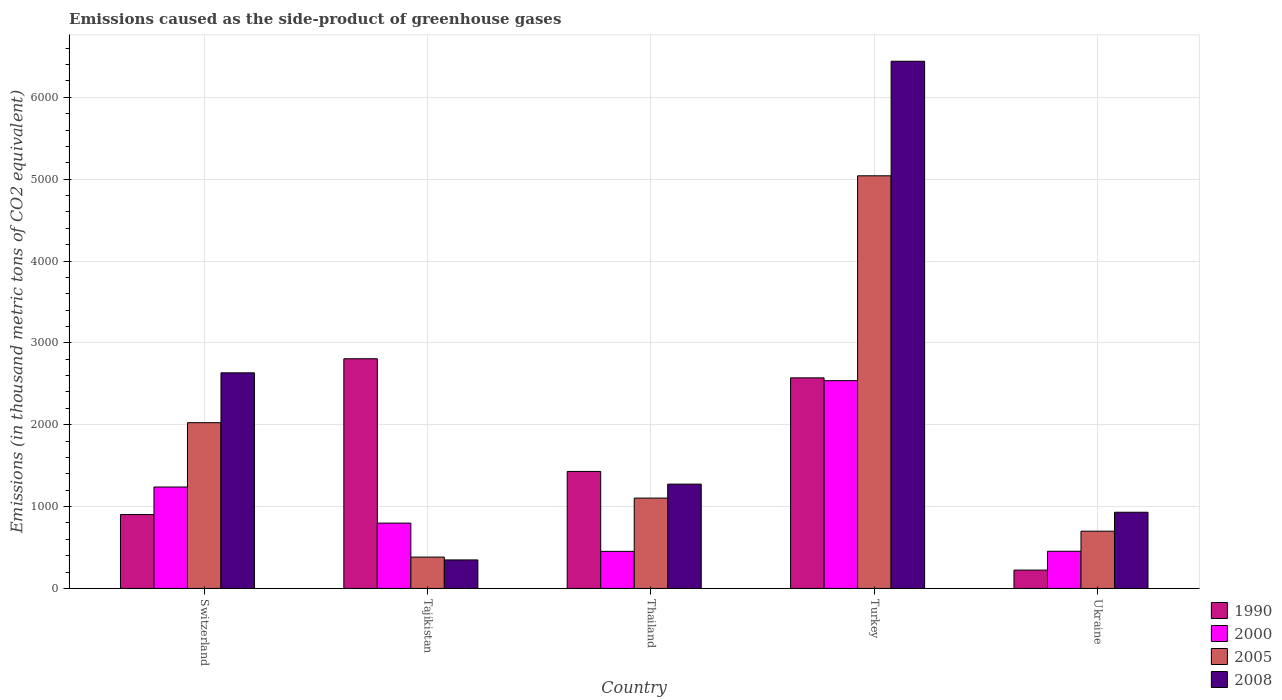How many groups of bars are there?
Your response must be concise. 5. Are the number of bars per tick equal to the number of legend labels?
Keep it short and to the point. Yes. How many bars are there on the 4th tick from the right?
Keep it short and to the point. 4. What is the label of the 3rd group of bars from the left?
Your answer should be very brief. Thailand. In how many cases, is the number of bars for a given country not equal to the number of legend labels?
Your answer should be compact. 0. What is the emissions caused as the side-product of greenhouse gases in 2000 in Ukraine?
Your response must be concise. 454.2. Across all countries, what is the maximum emissions caused as the side-product of greenhouse gases in 2000?
Your answer should be compact. 2538.5. Across all countries, what is the minimum emissions caused as the side-product of greenhouse gases in 2008?
Offer a terse response. 348.3. In which country was the emissions caused as the side-product of greenhouse gases in 2008 minimum?
Your answer should be compact. Tajikistan. What is the total emissions caused as the side-product of greenhouse gases in 1990 in the graph?
Your response must be concise. 7935. What is the difference between the emissions caused as the side-product of greenhouse gases in 1990 in Tajikistan and that in Turkey?
Your response must be concise. 233.4. What is the difference between the emissions caused as the side-product of greenhouse gases in 2008 in Tajikistan and the emissions caused as the side-product of greenhouse gases in 1990 in Switzerland?
Ensure brevity in your answer.  -554.3. What is the average emissions caused as the side-product of greenhouse gases in 2000 per country?
Ensure brevity in your answer.  1096.6. What is the difference between the emissions caused as the side-product of greenhouse gases of/in 2008 and emissions caused as the side-product of greenhouse gases of/in 2005 in Switzerland?
Make the answer very short. 609.1. What is the ratio of the emissions caused as the side-product of greenhouse gases in 2000 in Tajikistan to that in Turkey?
Your answer should be compact. 0.31. Is the emissions caused as the side-product of greenhouse gases in 2008 in Tajikistan less than that in Ukraine?
Give a very brief answer. Yes. Is the difference between the emissions caused as the side-product of greenhouse gases in 2008 in Switzerland and Tajikistan greater than the difference between the emissions caused as the side-product of greenhouse gases in 2005 in Switzerland and Tajikistan?
Offer a very short reply. Yes. What is the difference between the highest and the second highest emissions caused as the side-product of greenhouse gases in 2005?
Give a very brief answer. 3016.3. What is the difference between the highest and the lowest emissions caused as the side-product of greenhouse gases in 2000?
Provide a short and direct response. 2085.4. In how many countries, is the emissions caused as the side-product of greenhouse gases in 2005 greater than the average emissions caused as the side-product of greenhouse gases in 2005 taken over all countries?
Keep it short and to the point. 2. Is the sum of the emissions caused as the side-product of greenhouse gases in 2005 in Switzerland and Tajikistan greater than the maximum emissions caused as the side-product of greenhouse gases in 1990 across all countries?
Ensure brevity in your answer.  No. Is it the case that in every country, the sum of the emissions caused as the side-product of greenhouse gases in 2000 and emissions caused as the side-product of greenhouse gases in 1990 is greater than the sum of emissions caused as the side-product of greenhouse gases in 2008 and emissions caused as the side-product of greenhouse gases in 2005?
Offer a terse response. No. What does the 4th bar from the right in Thailand represents?
Ensure brevity in your answer.  1990. Is it the case that in every country, the sum of the emissions caused as the side-product of greenhouse gases in 2005 and emissions caused as the side-product of greenhouse gases in 2008 is greater than the emissions caused as the side-product of greenhouse gases in 1990?
Provide a succinct answer. No. How many bars are there?
Your answer should be very brief. 20. Are all the bars in the graph horizontal?
Make the answer very short. No. What is the difference between two consecutive major ticks on the Y-axis?
Give a very brief answer. 1000. Are the values on the major ticks of Y-axis written in scientific E-notation?
Your response must be concise. No. Does the graph contain any zero values?
Keep it short and to the point. No. Does the graph contain grids?
Give a very brief answer. Yes. What is the title of the graph?
Make the answer very short. Emissions caused as the side-product of greenhouse gases. What is the label or title of the X-axis?
Offer a very short reply. Country. What is the label or title of the Y-axis?
Give a very brief answer. Emissions (in thousand metric tons of CO2 equivalent). What is the Emissions (in thousand metric tons of CO2 equivalent) in 1990 in Switzerland?
Keep it short and to the point. 902.6. What is the Emissions (in thousand metric tons of CO2 equivalent) in 2000 in Switzerland?
Your response must be concise. 1239.2. What is the Emissions (in thousand metric tons of CO2 equivalent) of 2005 in Switzerland?
Offer a very short reply. 2025. What is the Emissions (in thousand metric tons of CO2 equivalent) in 2008 in Switzerland?
Provide a short and direct response. 2634.1. What is the Emissions (in thousand metric tons of CO2 equivalent) in 1990 in Tajikistan?
Offer a terse response. 2806.1. What is the Emissions (in thousand metric tons of CO2 equivalent) of 2000 in Tajikistan?
Offer a terse response. 798. What is the Emissions (in thousand metric tons of CO2 equivalent) of 2005 in Tajikistan?
Give a very brief answer. 383. What is the Emissions (in thousand metric tons of CO2 equivalent) of 2008 in Tajikistan?
Offer a very short reply. 348.3. What is the Emissions (in thousand metric tons of CO2 equivalent) in 1990 in Thailand?
Provide a succinct answer. 1429.5. What is the Emissions (in thousand metric tons of CO2 equivalent) in 2000 in Thailand?
Your answer should be very brief. 453.1. What is the Emissions (in thousand metric tons of CO2 equivalent) in 2005 in Thailand?
Make the answer very short. 1103.9. What is the Emissions (in thousand metric tons of CO2 equivalent) of 2008 in Thailand?
Keep it short and to the point. 1274.5. What is the Emissions (in thousand metric tons of CO2 equivalent) in 1990 in Turkey?
Your answer should be compact. 2572.7. What is the Emissions (in thousand metric tons of CO2 equivalent) in 2000 in Turkey?
Provide a short and direct response. 2538.5. What is the Emissions (in thousand metric tons of CO2 equivalent) of 2005 in Turkey?
Provide a short and direct response. 5041.3. What is the Emissions (in thousand metric tons of CO2 equivalent) of 2008 in Turkey?
Your answer should be compact. 6441. What is the Emissions (in thousand metric tons of CO2 equivalent) of 1990 in Ukraine?
Your answer should be compact. 224.1. What is the Emissions (in thousand metric tons of CO2 equivalent) of 2000 in Ukraine?
Make the answer very short. 454.2. What is the Emissions (in thousand metric tons of CO2 equivalent) of 2005 in Ukraine?
Your response must be concise. 699.3. What is the Emissions (in thousand metric tons of CO2 equivalent) in 2008 in Ukraine?
Your response must be concise. 930.6. Across all countries, what is the maximum Emissions (in thousand metric tons of CO2 equivalent) in 1990?
Provide a succinct answer. 2806.1. Across all countries, what is the maximum Emissions (in thousand metric tons of CO2 equivalent) of 2000?
Ensure brevity in your answer.  2538.5. Across all countries, what is the maximum Emissions (in thousand metric tons of CO2 equivalent) in 2005?
Your response must be concise. 5041.3. Across all countries, what is the maximum Emissions (in thousand metric tons of CO2 equivalent) of 2008?
Offer a terse response. 6441. Across all countries, what is the minimum Emissions (in thousand metric tons of CO2 equivalent) of 1990?
Offer a terse response. 224.1. Across all countries, what is the minimum Emissions (in thousand metric tons of CO2 equivalent) of 2000?
Your response must be concise. 453.1. Across all countries, what is the minimum Emissions (in thousand metric tons of CO2 equivalent) of 2005?
Provide a succinct answer. 383. Across all countries, what is the minimum Emissions (in thousand metric tons of CO2 equivalent) of 2008?
Provide a short and direct response. 348.3. What is the total Emissions (in thousand metric tons of CO2 equivalent) in 1990 in the graph?
Your answer should be very brief. 7935. What is the total Emissions (in thousand metric tons of CO2 equivalent) of 2000 in the graph?
Give a very brief answer. 5483. What is the total Emissions (in thousand metric tons of CO2 equivalent) of 2005 in the graph?
Make the answer very short. 9252.5. What is the total Emissions (in thousand metric tons of CO2 equivalent) in 2008 in the graph?
Provide a succinct answer. 1.16e+04. What is the difference between the Emissions (in thousand metric tons of CO2 equivalent) in 1990 in Switzerland and that in Tajikistan?
Offer a very short reply. -1903.5. What is the difference between the Emissions (in thousand metric tons of CO2 equivalent) of 2000 in Switzerland and that in Tajikistan?
Offer a very short reply. 441.2. What is the difference between the Emissions (in thousand metric tons of CO2 equivalent) of 2005 in Switzerland and that in Tajikistan?
Provide a short and direct response. 1642. What is the difference between the Emissions (in thousand metric tons of CO2 equivalent) in 2008 in Switzerland and that in Tajikistan?
Your answer should be compact. 2285.8. What is the difference between the Emissions (in thousand metric tons of CO2 equivalent) in 1990 in Switzerland and that in Thailand?
Your answer should be very brief. -526.9. What is the difference between the Emissions (in thousand metric tons of CO2 equivalent) in 2000 in Switzerland and that in Thailand?
Your answer should be compact. 786.1. What is the difference between the Emissions (in thousand metric tons of CO2 equivalent) of 2005 in Switzerland and that in Thailand?
Your answer should be very brief. 921.1. What is the difference between the Emissions (in thousand metric tons of CO2 equivalent) of 2008 in Switzerland and that in Thailand?
Make the answer very short. 1359.6. What is the difference between the Emissions (in thousand metric tons of CO2 equivalent) in 1990 in Switzerland and that in Turkey?
Your response must be concise. -1670.1. What is the difference between the Emissions (in thousand metric tons of CO2 equivalent) of 2000 in Switzerland and that in Turkey?
Make the answer very short. -1299.3. What is the difference between the Emissions (in thousand metric tons of CO2 equivalent) in 2005 in Switzerland and that in Turkey?
Ensure brevity in your answer.  -3016.3. What is the difference between the Emissions (in thousand metric tons of CO2 equivalent) in 2008 in Switzerland and that in Turkey?
Provide a short and direct response. -3806.9. What is the difference between the Emissions (in thousand metric tons of CO2 equivalent) of 1990 in Switzerland and that in Ukraine?
Offer a very short reply. 678.5. What is the difference between the Emissions (in thousand metric tons of CO2 equivalent) of 2000 in Switzerland and that in Ukraine?
Offer a very short reply. 785. What is the difference between the Emissions (in thousand metric tons of CO2 equivalent) of 2005 in Switzerland and that in Ukraine?
Provide a short and direct response. 1325.7. What is the difference between the Emissions (in thousand metric tons of CO2 equivalent) of 2008 in Switzerland and that in Ukraine?
Your response must be concise. 1703.5. What is the difference between the Emissions (in thousand metric tons of CO2 equivalent) of 1990 in Tajikistan and that in Thailand?
Offer a terse response. 1376.6. What is the difference between the Emissions (in thousand metric tons of CO2 equivalent) in 2000 in Tajikistan and that in Thailand?
Your answer should be compact. 344.9. What is the difference between the Emissions (in thousand metric tons of CO2 equivalent) of 2005 in Tajikistan and that in Thailand?
Your response must be concise. -720.9. What is the difference between the Emissions (in thousand metric tons of CO2 equivalent) of 2008 in Tajikistan and that in Thailand?
Your response must be concise. -926.2. What is the difference between the Emissions (in thousand metric tons of CO2 equivalent) in 1990 in Tajikistan and that in Turkey?
Your answer should be compact. 233.4. What is the difference between the Emissions (in thousand metric tons of CO2 equivalent) in 2000 in Tajikistan and that in Turkey?
Offer a very short reply. -1740.5. What is the difference between the Emissions (in thousand metric tons of CO2 equivalent) in 2005 in Tajikistan and that in Turkey?
Provide a succinct answer. -4658.3. What is the difference between the Emissions (in thousand metric tons of CO2 equivalent) of 2008 in Tajikistan and that in Turkey?
Offer a very short reply. -6092.7. What is the difference between the Emissions (in thousand metric tons of CO2 equivalent) of 1990 in Tajikistan and that in Ukraine?
Ensure brevity in your answer.  2582. What is the difference between the Emissions (in thousand metric tons of CO2 equivalent) in 2000 in Tajikistan and that in Ukraine?
Your answer should be compact. 343.8. What is the difference between the Emissions (in thousand metric tons of CO2 equivalent) in 2005 in Tajikistan and that in Ukraine?
Your answer should be very brief. -316.3. What is the difference between the Emissions (in thousand metric tons of CO2 equivalent) of 2008 in Tajikistan and that in Ukraine?
Your answer should be compact. -582.3. What is the difference between the Emissions (in thousand metric tons of CO2 equivalent) of 1990 in Thailand and that in Turkey?
Your response must be concise. -1143.2. What is the difference between the Emissions (in thousand metric tons of CO2 equivalent) in 2000 in Thailand and that in Turkey?
Your answer should be compact. -2085.4. What is the difference between the Emissions (in thousand metric tons of CO2 equivalent) in 2005 in Thailand and that in Turkey?
Provide a short and direct response. -3937.4. What is the difference between the Emissions (in thousand metric tons of CO2 equivalent) of 2008 in Thailand and that in Turkey?
Give a very brief answer. -5166.5. What is the difference between the Emissions (in thousand metric tons of CO2 equivalent) in 1990 in Thailand and that in Ukraine?
Ensure brevity in your answer.  1205.4. What is the difference between the Emissions (in thousand metric tons of CO2 equivalent) in 2000 in Thailand and that in Ukraine?
Your answer should be very brief. -1.1. What is the difference between the Emissions (in thousand metric tons of CO2 equivalent) of 2005 in Thailand and that in Ukraine?
Provide a short and direct response. 404.6. What is the difference between the Emissions (in thousand metric tons of CO2 equivalent) in 2008 in Thailand and that in Ukraine?
Keep it short and to the point. 343.9. What is the difference between the Emissions (in thousand metric tons of CO2 equivalent) of 1990 in Turkey and that in Ukraine?
Ensure brevity in your answer.  2348.6. What is the difference between the Emissions (in thousand metric tons of CO2 equivalent) of 2000 in Turkey and that in Ukraine?
Provide a short and direct response. 2084.3. What is the difference between the Emissions (in thousand metric tons of CO2 equivalent) of 2005 in Turkey and that in Ukraine?
Make the answer very short. 4342. What is the difference between the Emissions (in thousand metric tons of CO2 equivalent) in 2008 in Turkey and that in Ukraine?
Ensure brevity in your answer.  5510.4. What is the difference between the Emissions (in thousand metric tons of CO2 equivalent) in 1990 in Switzerland and the Emissions (in thousand metric tons of CO2 equivalent) in 2000 in Tajikistan?
Your answer should be very brief. 104.6. What is the difference between the Emissions (in thousand metric tons of CO2 equivalent) of 1990 in Switzerland and the Emissions (in thousand metric tons of CO2 equivalent) of 2005 in Tajikistan?
Offer a terse response. 519.6. What is the difference between the Emissions (in thousand metric tons of CO2 equivalent) in 1990 in Switzerland and the Emissions (in thousand metric tons of CO2 equivalent) in 2008 in Tajikistan?
Your response must be concise. 554.3. What is the difference between the Emissions (in thousand metric tons of CO2 equivalent) in 2000 in Switzerland and the Emissions (in thousand metric tons of CO2 equivalent) in 2005 in Tajikistan?
Offer a terse response. 856.2. What is the difference between the Emissions (in thousand metric tons of CO2 equivalent) in 2000 in Switzerland and the Emissions (in thousand metric tons of CO2 equivalent) in 2008 in Tajikistan?
Give a very brief answer. 890.9. What is the difference between the Emissions (in thousand metric tons of CO2 equivalent) in 2005 in Switzerland and the Emissions (in thousand metric tons of CO2 equivalent) in 2008 in Tajikistan?
Your response must be concise. 1676.7. What is the difference between the Emissions (in thousand metric tons of CO2 equivalent) of 1990 in Switzerland and the Emissions (in thousand metric tons of CO2 equivalent) of 2000 in Thailand?
Ensure brevity in your answer.  449.5. What is the difference between the Emissions (in thousand metric tons of CO2 equivalent) of 1990 in Switzerland and the Emissions (in thousand metric tons of CO2 equivalent) of 2005 in Thailand?
Your answer should be compact. -201.3. What is the difference between the Emissions (in thousand metric tons of CO2 equivalent) in 1990 in Switzerland and the Emissions (in thousand metric tons of CO2 equivalent) in 2008 in Thailand?
Give a very brief answer. -371.9. What is the difference between the Emissions (in thousand metric tons of CO2 equivalent) in 2000 in Switzerland and the Emissions (in thousand metric tons of CO2 equivalent) in 2005 in Thailand?
Your answer should be compact. 135.3. What is the difference between the Emissions (in thousand metric tons of CO2 equivalent) of 2000 in Switzerland and the Emissions (in thousand metric tons of CO2 equivalent) of 2008 in Thailand?
Offer a terse response. -35.3. What is the difference between the Emissions (in thousand metric tons of CO2 equivalent) in 2005 in Switzerland and the Emissions (in thousand metric tons of CO2 equivalent) in 2008 in Thailand?
Offer a terse response. 750.5. What is the difference between the Emissions (in thousand metric tons of CO2 equivalent) in 1990 in Switzerland and the Emissions (in thousand metric tons of CO2 equivalent) in 2000 in Turkey?
Ensure brevity in your answer.  -1635.9. What is the difference between the Emissions (in thousand metric tons of CO2 equivalent) of 1990 in Switzerland and the Emissions (in thousand metric tons of CO2 equivalent) of 2005 in Turkey?
Offer a very short reply. -4138.7. What is the difference between the Emissions (in thousand metric tons of CO2 equivalent) in 1990 in Switzerland and the Emissions (in thousand metric tons of CO2 equivalent) in 2008 in Turkey?
Your answer should be very brief. -5538.4. What is the difference between the Emissions (in thousand metric tons of CO2 equivalent) of 2000 in Switzerland and the Emissions (in thousand metric tons of CO2 equivalent) of 2005 in Turkey?
Your response must be concise. -3802.1. What is the difference between the Emissions (in thousand metric tons of CO2 equivalent) in 2000 in Switzerland and the Emissions (in thousand metric tons of CO2 equivalent) in 2008 in Turkey?
Your response must be concise. -5201.8. What is the difference between the Emissions (in thousand metric tons of CO2 equivalent) in 2005 in Switzerland and the Emissions (in thousand metric tons of CO2 equivalent) in 2008 in Turkey?
Provide a succinct answer. -4416. What is the difference between the Emissions (in thousand metric tons of CO2 equivalent) in 1990 in Switzerland and the Emissions (in thousand metric tons of CO2 equivalent) in 2000 in Ukraine?
Keep it short and to the point. 448.4. What is the difference between the Emissions (in thousand metric tons of CO2 equivalent) of 1990 in Switzerland and the Emissions (in thousand metric tons of CO2 equivalent) of 2005 in Ukraine?
Provide a short and direct response. 203.3. What is the difference between the Emissions (in thousand metric tons of CO2 equivalent) of 1990 in Switzerland and the Emissions (in thousand metric tons of CO2 equivalent) of 2008 in Ukraine?
Ensure brevity in your answer.  -28. What is the difference between the Emissions (in thousand metric tons of CO2 equivalent) of 2000 in Switzerland and the Emissions (in thousand metric tons of CO2 equivalent) of 2005 in Ukraine?
Offer a terse response. 539.9. What is the difference between the Emissions (in thousand metric tons of CO2 equivalent) in 2000 in Switzerland and the Emissions (in thousand metric tons of CO2 equivalent) in 2008 in Ukraine?
Ensure brevity in your answer.  308.6. What is the difference between the Emissions (in thousand metric tons of CO2 equivalent) of 2005 in Switzerland and the Emissions (in thousand metric tons of CO2 equivalent) of 2008 in Ukraine?
Your answer should be compact. 1094.4. What is the difference between the Emissions (in thousand metric tons of CO2 equivalent) in 1990 in Tajikistan and the Emissions (in thousand metric tons of CO2 equivalent) in 2000 in Thailand?
Make the answer very short. 2353. What is the difference between the Emissions (in thousand metric tons of CO2 equivalent) in 1990 in Tajikistan and the Emissions (in thousand metric tons of CO2 equivalent) in 2005 in Thailand?
Give a very brief answer. 1702.2. What is the difference between the Emissions (in thousand metric tons of CO2 equivalent) of 1990 in Tajikistan and the Emissions (in thousand metric tons of CO2 equivalent) of 2008 in Thailand?
Keep it short and to the point. 1531.6. What is the difference between the Emissions (in thousand metric tons of CO2 equivalent) of 2000 in Tajikistan and the Emissions (in thousand metric tons of CO2 equivalent) of 2005 in Thailand?
Your answer should be very brief. -305.9. What is the difference between the Emissions (in thousand metric tons of CO2 equivalent) in 2000 in Tajikistan and the Emissions (in thousand metric tons of CO2 equivalent) in 2008 in Thailand?
Make the answer very short. -476.5. What is the difference between the Emissions (in thousand metric tons of CO2 equivalent) of 2005 in Tajikistan and the Emissions (in thousand metric tons of CO2 equivalent) of 2008 in Thailand?
Make the answer very short. -891.5. What is the difference between the Emissions (in thousand metric tons of CO2 equivalent) in 1990 in Tajikistan and the Emissions (in thousand metric tons of CO2 equivalent) in 2000 in Turkey?
Keep it short and to the point. 267.6. What is the difference between the Emissions (in thousand metric tons of CO2 equivalent) of 1990 in Tajikistan and the Emissions (in thousand metric tons of CO2 equivalent) of 2005 in Turkey?
Offer a very short reply. -2235.2. What is the difference between the Emissions (in thousand metric tons of CO2 equivalent) of 1990 in Tajikistan and the Emissions (in thousand metric tons of CO2 equivalent) of 2008 in Turkey?
Your answer should be compact. -3634.9. What is the difference between the Emissions (in thousand metric tons of CO2 equivalent) of 2000 in Tajikistan and the Emissions (in thousand metric tons of CO2 equivalent) of 2005 in Turkey?
Make the answer very short. -4243.3. What is the difference between the Emissions (in thousand metric tons of CO2 equivalent) of 2000 in Tajikistan and the Emissions (in thousand metric tons of CO2 equivalent) of 2008 in Turkey?
Provide a short and direct response. -5643. What is the difference between the Emissions (in thousand metric tons of CO2 equivalent) in 2005 in Tajikistan and the Emissions (in thousand metric tons of CO2 equivalent) in 2008 in Turkey?
Your answer should be very brief. -6058. What is the difference between the Emissions (in thousand metric tons of CO2 equivalent) in 1990 in Tajikistan and the Emissions (in thousand metric tons of CO2 equivalent) in 2000 in Ukraine?
Provide a succinct answer. 2351.9. What is the difference between the Emissions (in thousand metric tons of CO2 equivalent) of 1990 in Tajikistan and the Emissions (in thousand metric tons of CO2 equivalent) of 2005 in Ukraine?
Your response must be concise. 2106.8. What is the difference between the Emissions (in thousand metric tons of CO2 equivalent) of 1990 in Tajikistan and the Emissions (in thousand metric tons of CO2 equivalent) of 2008 in Ukraine?
Give a very brief answer. 1875.5. What is the difference between the Emissions (in thousand metric tons of CO2 equivalent) in 2000 in Tajikistan and the Emissions (in thousand metric tons of CO2 equivalent) in 2005 in Ukraine?
Your answer should be compact. 98.7. What is the difference between the Emissions (in thousand metric tons of CO2 equivalent) in 2000 in Tajikistan and the Emissions (in thousand metric tons of CO2 equivalent) in 2008 in Ukraine?
Your response must be concise. -132.6. What is the difference between the Emissions (in thousand metric tons of CO2 equivalent) of 2005 in Tajikistan and the Emissions (in thousand metric tons of CO2 equivalent) of 2008 in Ukraine?
Make the answer very short. -547.6. What is the difference between the Emissions (in thousand metric tons of CO2 equivalent) in 1990 in Thailand and the Emissions (in thousand metric tons of CO2 equivalent) in 2000 in Turkey?
Ensure brevity in your answer.  -1109. What is the difference between the Emissions (in thousand metric tons of CO2 equivalent) of 1990 in Thailand and the Emissions (in thousand metric tons of CO2 equivalent) of 2005 in Turkey?
Provide a succinct answer. -3611.8. What is the difference between the Emissions (in thousand metric tons of CO2 equivalent) of 1990 in Thailand and the Emissions (in thousand metric tons of CO2 equivalent) of 2008 in Turkey?
Your response must be concise. -5011.5. What is the difference between the Emissions (in thousand metric tons of CO2 equivalent) of 2000 in Thailand and the Emissions (in thousand metric tons of CO2 equivalent) of 2005 in Turkey?
Provide a succinct answer. -4588.2. What is the difference between the Emissions (in thousand metric tons of CO2 equivalent) in 2000 in Thailand and the Emissions (in thousand metric tons of CO2 equivalent) in 2008 in Turkey?
Make the answer very short. -5987.9. What is the difference between the Emissions (in thousand metric tons of CO2 equivalent) of 2005 in Thailand and the Emissions (in thousand metric tons of CO2 equivalent) of 2008 in Turkey?
Ensure brevity in your answer.  -5337.1. What is the difference between the Emissions (in thousand metric tons of CO2 equivalent) in 1990 in Thailand and the Emissions (in thousand metric tons of CO2 equivalent) in 2000 in Ukraine?
Keep it short and to the point. 975.3. What is the difference between the Emissions (in thousand metric tons of CO2 equivalent) in 1990 in Thailand and the Emissions (in thousand metric tons of CO2 equivalent) in 2005 in Ukraine?
Your response must be concise. 730.2. What is the difference between the Emissions (in thousand metric tons of CO2 equivalent) of 1990 in Thailand and the Emissions (in thousand metric tons of CO2 equivalent) of 2008 in Ukraine?
Ensure brevity in your answer.  498.9. What is the difference between the Emissions (in thousand metric tons of CO2 equivalent) of 2000 in Thailand and the Emissions (in thousand metric tons of CO2 equivalent) of 2005 in Ukraine?
Your response must be concise. -246.2. What is the difference between the Emissions (in thousand metric tons of CO2 equivalent) of 2000 in Thailand and the Emissions (in thousand metric tons of CO2 equivalent) of 2008 in Ukraine?
Your answer should be very brief. -477.5. What is the difference between the Emissions (in thousand metric tons of CO2 equivalent) of 2005 in Thailand and the Emissions (in thousand metric tons of CO2 equivalent) of 2008 in Ukraine?
Give a very brief answer. 173.3. What is the difference between the Emissions (in thousand metric tons of CO2 equivalent) in 1990 in Turkey and the Emissions (in thousand metric tons of CO2 equivalent) in 2000 in Ukraine?
Offer a very short reply. 2118.5. What is the difference between the Emissions (in thousand metric tons of CO2 equivalent) of 1990 in Turkey and the Emissions (in thousand metric tons of CO2 equivalent) of 2005 in Ukraine?
Keep it short and to the point. 1873.4. What is the difference between the Emissions (in thousand metric tons of CO2 equivalent) in 1990 in Turkey and the Emissions (in thousand metric tons of CO2 equivalent) in 2008 in Ukraine?
Keep it short and to the point. 1642.1. What is the difference between the Emissions (in thousand metric tons of CO2 equivalent) of 2000 in Turkey and the Emissions (in thousand metric tons of CO2 equivalent) of 2005 in Ukraine?
Make the answer very short. 1839.2. What is the difference between the Emissions (in thousand metric tons of CO2 equivalent) in 2000 in Turkey and the Emissions (in thousand metric tons of CO2 equivalent) in 2008 in Ukraine?
Ensure brevity in your answer.  1607.9. What is the difference between the Emissions (in thousand metric tons of CO2 equivalent) in 2005 in Turkey and the Emissions (in thousand metric tons of CO2 equivalent) in 2008 in Ukraine?
Provide a succinct answer. 4110.7. What is the average Emissions (in thousand metric tons of CO2 equivalent) in 1990 per country?
Give a very brief answer. 1587. What is the average Emissions (in thousand metric tons of CO2 equivalent) in 2000 per country?
Ensure brevity in your answer.  1096.6. What is the average Emissions (in thousand metric tons of CO2 equivalent) in 2005 per country?
Provide a short and direct response. 1850.5. What is the average Emissions (in thousand metric tons of CO2 equivalent) in 2008 per country?
Keep it short and to the point. 2325.7. What is the difference between the Emissions (in thousand metric tons of CO2 equivalent) of 1990 and Emissions (in thousand metric tons of CO2 equivalent) of 2000 in Switzerland?
Make the answer very short. -336.6. What is the difference between the Emissions (in thousand metric tons of CO2 equivalent) of 1990 and Emissions (in thousand metric tons of CO2 equivalent) of 2005 in Switzerland?
Offer a very short reply. -1122.4. What is the difference between the Emissions (in thousand metric tons of CO2 equivalent) in 1990 and Emissions (in thousand metric tons of CO2 equivalent) in 2008 in Switzerland?
Your response must be concise. -1731.5. What is the difference between the Emissions (in thousand metric tons of CO2 equivalent) of 2000 and Emissions (in thousand metric tons of CO2 equivalent) of 2005 in Switzerland?
Offer a terse response. -785.8. What is the difference between the Emissions (in thousand metric tons of CO2 equivalent) in 2000 and Emissions (in thousand metric tons of CO2 equivalent) in 2008 in Switzerland?
Make the answer very short. -1394.9. What is the difference between the Emissions (in thousand metric tons of CO2 equivalent) of 2005 and Emissions (in thousand metric tons of CO2 equivalent) of 2008 in Switzerland?
Offer a terse response. -609.1. What is the difference between the Emissions (in thousand metric tons of CO2 equivalent) of 1990 and Emissions (in thousand metric tons of CO2 equivalent) of 2000 in Tajikistan?
Provide a succinct answer. 2008.1. What is the difference between the Emissions (in thousand metric tons of CO2 equivalent) in 1990 and Emissions (in thousand metric tons of CO2 equivalent) in 2005 in Tajikistan?
Your response must be concise. 2423.1. What is the difference between the Emissions (in thousand metric tons of CO2 equivalent) of 1990 and Emissions (in thousand metric tons of CO2 equivalent) of 2008 in Tajikistan?
Provide a succinct answer. 2457.8. What is the difference between the Emissions (in thousand metric tons of CO2 equivalent) of 2000 and Emissions (in thousand metric tons of CO2 equivalent) of 2005 in Tajikistan?
Make the answer very short. 415. What is the difference between the Emissions (in thousand metric tons of CO2 equivalent) in 2000 and Emissions (in thousand metric tons of CO2 equivalent) in 2008 in Tajikistan?
Provide a short and direct response. 449.7. What is the difference between the Emissions (in thousand metric tons of CO2 equivalent) of 2005 and Emissions (in thousand metric tons of CO2 equivalent) of 2008 in Tajikistan?
Offer a terse response. 34.7. What is the difference between the Emissions (in thousand metric tons of CO2 equivalent) in 1990 and Emissions (in thousand metric tons of CO2 equivalent) in 2000 in Thailand?
Provide a short and direct response. 976.4. What is the difference between the Emissions (in thousand metric tons of CO2 equivalent) in 1990 and Emissions (in thousand metric tons of CO2 equivalent) in 2005 in Thailand?
Provide a short and direct response. 325.6. What is the difference between the Emissions (in thousand metric tons of CO2 equivalent) of 1990 and Emissions (in thousand metric tons of CO2 equivalent) of 2008 in Thailand?
Your response must be concise. 155. What is the difference between the Emissions (in thousand metric tons of CO2 equivalent) in 2000 and Emissions (in thousand metric tons of CO2 equivalent) in 2005 in Thailand?
Your answer should be compact. -650.8. What is the difference between the Emissions (in thousand metric tons of CO2 equivalent) of 2000 and Emissions (in thousand metric tons of CO2 equivalent) of 2008 in Thailand?
Give a very brief answer. -821.4. What is the difference between the Emissions (in thousand metric tons of CO2 equivalent) of 2005 and Emissions (in thousand metric tons of CO2 equivalent) of 2008 in Thailand?
Your response must be concise. -170.6. What is the difference between the Emissions (in thousand metric tons of CO2 equivalent) in 1990 and Emissions (in thousand metric tons of CO2 equivalent) in 2000 in Turkey?
Provide a short and direct response. 34.2. What is the difference between the Emissions (in thousand metric tons of CO2 equivalent) of 1990 and Emissions (in thousand metric tons of CO2 equivalent) of 2005 in Turkey?
Your answer should be very brief. -2468.6. What is the difference between the Emissions (in thousand metric tons of CO2 equivalent) in 1990 and Emissions (in thousand metric tons of CO2 equivalent) in 2008 in Turkey?
Offer a very short reply. -3868.3. What is the difference between the Emissions (in thousand metric tons of CO2 equivalent) of 2000 and Emissions (in thousand metric tons of CO2 equivalent) of 2005 in Turkey?
Keep it short and to the point. -2502.8. What is the difference between the Emissions (in thousand metric tons of CO2 equivalent) of 2000 and Emissions (in thousand metric tons of CO2 equivalent) of 2008 in Turkey?
Offer a terse response. -3902.5. What is the difference between the Emissions (in thousand metric tons of CO2 equivalent) of 2005 and Emissions (in thousand metric tons of CO2 equivalent) of 2008 in Turkey?
Your response must be concise. -1399.7. What is the difference between the Emissions (in thousand metric tons of CO2 equivalent) of 1990 and Emissions (in thousand metric tons of CO2 equivalent) of 2000 in Ukraine?
Keep it short and to the point. -230.1. What is the difference between the Emissions (in thousand metric tons of CO2 equivalent) in 1990 and Emissions (in thousand metric tons of CO2 equivalent) in 2005 in Ukraine?
Your response must be concise. -475.2. What is the difference between the Emissions (in thousand metric tons of CO2 equivalent) in 1990 and Emissions (in thousand metric tons of CO2 equivalent) in 2008 in Ukraine?
Provide a short and direct response. -706.5. What is the difference between the Emissions (in thousand metric tons of CO2 equivalent) in 2000 and Emissions (in thousand metric tons of CO2 equivalent) in 2005 in Ukraine?
Your response must be concise. -245.1. What is the difference between the Emissions (in thousand metric tons of CO2 equivalent) of 2000 and Emissions (in thousand metric tons of CO2 equivalent) of 2008 in Ukraine?
Keep it short and to the point. -476.4. What is the difference between the Emissions (in thousand metric tons of CO2 equivalent) in 2005 and Emissions (in thousand metric tons of CO2 equivalent) in 2008 in Ukraine?
Provide a succinct answer. -231.3. What is the ratio of the Emissions (in thousand metric tons of CO2 equivalent) of 1990 in Switzerland to that in Tajikistan?
Offer a very short reply. 0.32. What is the ratio of the Emissions (in thousand metric tons of CO2 equivalent) in 2000 in Switzerland to that in Tajikistan?
Make the answer very short. 1.55. What is the ratio of the Emissions (in thousand metric tons of CO2 equivalent) in 2005 in Switzerland to that in Tajikistan?
Your answer should be compact. 5.29. What is the ratio of the Emissions (in thousand metric tons of CO2 equivalent) in 2008 in Switzerland to that in Tajikistan?
Offer a terse response. 7.56. What is the ratio of the Emissions (in thousand metric tons of CO2 equivalent) in 1990 in Switzerland to that in Thailand?
Your answer should be very brief. 0.63. What is the ratio of the Emissions (in thousand metric tons of CO2 equivalent) in 2000 in Switzerland to that in Thailand?
Give a very brief answer. 2.73. What is the ratio of the Emissions (in thousand metric tons of CO2 equivalent) of 2005 in Switzerland to that in Thailand?
Provide a succinct answer. 1.83. What is the ratio of the Emissions (in thousand metric tons of CO2 equivalent) of 2008 in Switzerland to that in Thailand?
Your response must be concise. 2.07. What is the ratio of the Emissions (in thousand metric tons of CO2 equivalent) of 1990 in Switzerland to that in Turkey?
Offer a very short reply. 0.35. What is the ratio of the Emissions (in thousand metric tons of CO2 equivalent) in 2000 in Switzerland to that in Turkey?
Your answer should be compact. 0.49. What is the ratio of the Emissions (in thousand metric tons of CO2 equivalent) of 2005 in Switzerland to that in Turkey?
Offer a very short reply. 0.4. What is the ratio of the Emissions (in thousand metric tons of CO2 equivalent) of 2008 in Switzerland to that in Turkey?
Your answer should be very brief. 0.41. What is the ratio of the Emissions (in thousand metric tons of CO2 equivalent) of 1990 in Switzerland to that in Ukraine?
Make the answer very short. 4.03. What is the ratio of the Emissions (in thousand metric tons of CO2 equivalent) in 2000 in Switzerland to that in Ukraine?
Make the answer very short. 2.73. What is the ratio of the Emissions (in thousand metric tons of CO2 equivalent) of 2005 in Switzerland to that in Ukraine?
Give a very brief answer. 2.9. What is the ratio of the Emissions (in thousand metric tons of CO2 equivalent) in 2008 in Switzerland to that in Ukraine?
Make the answer very short. 2.83. What is the ratio of the Emissions (in thousand metric tons of CO2 equivalent) in 1990 in Tajikistan to that in Thailand?
Make the answer very short. 1.96. What is the ratio of the Emissions (in thousand metric tons of CO2 equivalent) in 2000 in Tajikistan to that in Thailand?
Offer a terse response. 1.76. What is the ratio of the Emissions (in thousand metric tons of CO2 equivalent) of 2005 in Tajikistan to that in Thailand?
Your answer should be compact. 0.35. What is the ratio of the Emissions (in thousand metric tons of CO2 equivalent) in 2008 in Tajikistan to that in Thailand?
Your response must be concise. 0.27. What is the ratio of the Emissions (in thousand metric tons of CO2 equivalent) in 1990 in Tajikistan to that in Turkey?
Offer a terse response. 1.09. What is the ratio of the Emissions (in thousand metric tons of CO2 equivalent) in 2000 in Tajikistan to that in Turkey?
Offer a very short reply. 0.31. What is the ratio of the Emissions (in thousand metric tons of CO2 equivalent) of 2005 in Tajikistan to that in Turkey?
Make the answer very short. 0.08. What is the ratio of the Emissions (in thousand metric tons of CO2 equivalent) of 2008 in Tajikistan to that in Turkey?
Give a very brief answer. 0.05. What is the ratio of the Emissions (in thousand metric tons of CO2 equivalent) in 1990 in Tajikistan to that in Ukraine?
Your answer should be compact. 12.52. What is the ratio of the Emissions (in thousand metric tons of CO2 equivalent) of 2000 in Tajikistan to that in Ukraine?
Offer a very short reply. 1.76. What is the ratio of the Emissions (in thousand metric tons of CO2 equivalent) of 2005 in Tajikistan to that in Ukraine?
Keep it short and to the point. 0.55. What is the ratio of the Emissions (in thousand metric tons of CO2 equivalent) of 2008 in Tajikistan to that in Ukraine?
Your answer should be compact. 0.37. What is the ratio of the Emissions (in thousand metric tons of CO2 equivalent) in 1990 in Thailand to that in Turkey?
Give a very brief answer. 0.56. What is the ratio of the Emissions (in thousand metric tons of CO2 equivalent) in 2000 in Thailand to that in Turkey?
Offer a very short reply. 0.18. What is the ratio of the Emissions (in thousand metric tons of CO2 equivalent) of 2005 in Thailand to that in Turkey?
Offer a terse response. 0.22. What is the ratio of the Emissions (in thousand metric tons of CO2 equivalent) of 2008 in Thailand to that in Turkey?
Your answer should be compact. 0.2. What is the ratio of the Emissions (in thousand metric tons of CO2 equivalent) of 1990 in Thailand to that in Ukraine?
Your answer should be compact. 6.38. What is the ratio of the Emissions (in thousand metric tons of CO2 equivalent) of 2000 in Thailand to that in Ukraine?
Your response must be concise. 1. What is the ratio of the Emissions (in thousand metric tons of CO2 equivalent) of 2005 in Thailand to that in Ukraine?
Ensure brevity in your answer.  1.58. What is the ratio of the Emissions (in thousand metric tons of CO2 equivalent) in 2008 in Thailand to that in Ukraine?
Ensure brevity in your answer.  1.37. What is the ratio of the Emissions (in thousand metric tons of CO2 equivalent) in 1990 in Turkey to that in Ukraine?
Offer a very short reply. 11.48. What is the ratio of the Emissions (in thousand metric tons of CO2 equivalent) in 2000 in Turkey to that in Ukraine?
Ensure brevity in your answer.  5.59. What is the ratio of the Emissions (in thousand metric tons of CO2 equivalent) of 2005 in Turkey to that in Ukraine?
Give a very brief answer. 7.21. What is the ratio of the Emissions (in thousand metric tons of CO2 equivalent) of 2008 in Turkey to that in Ukraine?
Your answer should be compact. 6.92. What is the difference between the highest and the second highest Emissions (in thousand metric tons of CO2 equivalent) of 1990?
Your answer should be compact. 233.4. What is the difference between the highest and the second highest Emissions (in thousand metric tons of CO2 equivalent) of 2000?
Offer a terse response. 1299.3. What is the difference between the highest and the second highest Emissions (in thousand metric tons of CO2 equivalent) in 2005?
Offer a terse response. 3016.3. What is the difference between the highest and the second highest Emissions (in thousand metric tons of CO2 equivalent) in 2008?
Keep it short and to the point. 3806.9. What is the difference between the highest and the lowest Emissions (in thousand metric tons of CO2 equivalent) of 1990?
Offer a terse response. 2582. What is the difference between the highest and the lowest Emissions (in thousand metric tons of CO2 equivalent) of 2000?
Ensure brevity in your answer.  2085.4. What is the difference between the highest and the lowest Emissions (in thousand metric tons of CO2 equivalent) in 2005?
Offer a terse response. 4658.3. What is the difference between the highest and the lowest Emissions (in thousand metric tons of CO2 equivalent) of 2008?
Offer a terse response. 6092.7. 